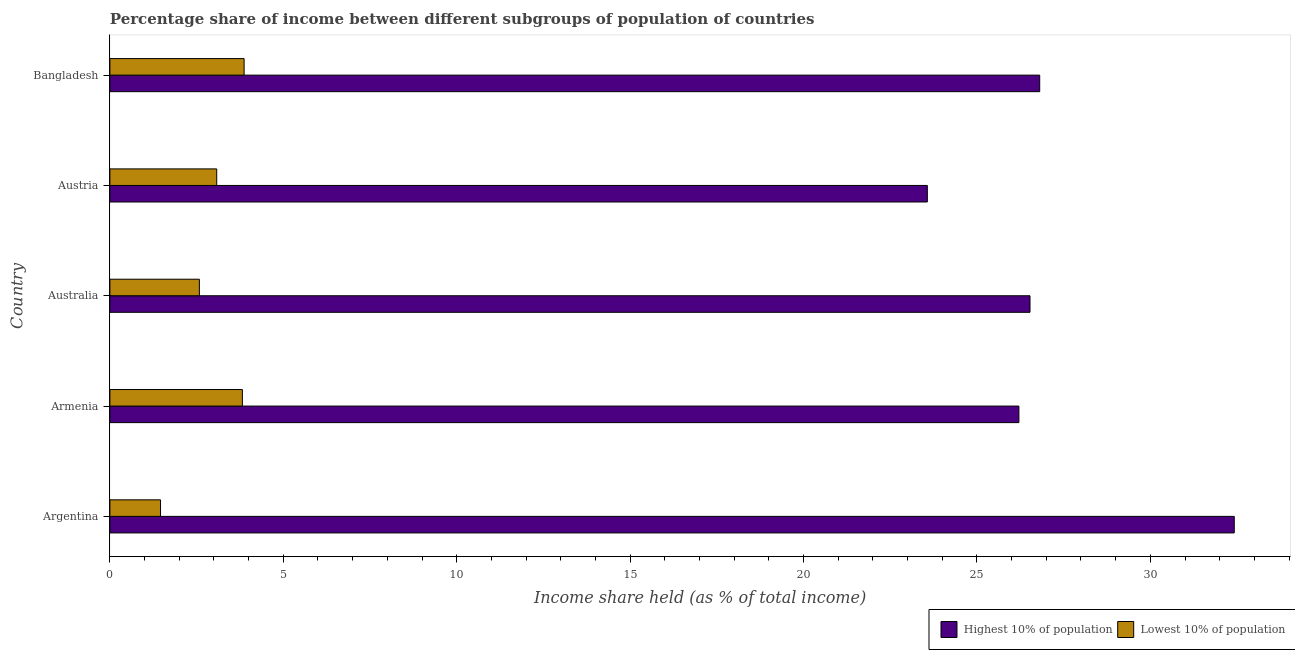How many different coloured bars are there?
Your answer should be compact. 2. How many groups of bars are there?
Provide a short and direct response. 5. Are the number of bars per tick equal to the number of legend labels?
Give a very brief answer. Yes. Are the number of bars on each tick of the Y-axis equal?
Your answer should be very brief. Yes. How many bars are there on the 2nd tick from the top?
Offer a very short reply. 2. What is the label of the 1st group of bars from the top?
Make the answer very short. Bangladesh. What is the income share held by lowest 10% of the population in Bangladesh?
Your answer should be compact. 3.87. Across all countries, what is the maximum income share held by highest 10% of the population?
Your answer should be very brief. 32.42. Across all countries, what is the minimum income share held by highest 10% of the population?
Give a very brief answer. 23.57. In which country was the income share held by lowest 10% of the population minimum?
Offer a terse response. Argentina. What is the total income share held by highest 10% of the population in the graph?
Give a very brief answer. 135.54. What is the difference between the income share held by highest 10% of the population in Austria and that in Bangladesh?
Your response must be concise. -3.24. What is the difference between the income share held by lowest 10% of the population in Argentina and the income share held by highest 10% of the population in Austria?
Your answer should be very brief. -22.11. What is the average income share held by lowest 10% of the population per country?
Ensure brevity in your answer.  2.96. What is the difference between the income share held by lowest 10% of the population and income share held by highest 10% of the population in Australia?
Give a very brief answer. -23.95. What is the ratio of the income share held by highest 10% of the population in Argentina to that in Australia?
Your answer should be compact. 1.22. Is the income share held by lowest 10% of the population in Argentina less than that in Australia?
Offer a very short reply. Yes. What is the difference between the highest and the second highest income share held by highest 10% of the population?
Your response must be concise. 5.61. What is the difference between the highest and the lowest income share held by highest 10% of the population?
Your answer should be compact. 8.85. In how many countries, is the income share held by highest 10% of the population greater than the average income share held by highest 10% of the population taken over all countries?
Give a very brief answer. 1. Is the sum of the income share held by lowest 10% of the population in Austria and Bangladesh greater than the maximum income share held by highest 10% of the population across all countries?
Your answer should be very brief. No. What does the 2nd bar from the top in Armenia represents?
Make the answer very short. Highest 10% of population. What does the 2nd bar from the bottom in Bangladesh represents?
Ensure brevity in your answer.  Lowest 10% of population. How many bars are there?
Keep it short and to the point. 10. What is the difference between two consecutive major ticks on the X-axis?
Offer a very short reply. 5. Does the graph contain any zero values?
Ensure brevity in your answer.  No. How many legend labels are there?
Keep it short and to the point. 2. How are the legend labels stacked?
Your answer should be compact. Horizontal. What is the title of the graph?
Keep it short and to the point. Percentage share of income between different subgroups of population of countries. Does "Diarrhea" appear as one of the legend labels in the graph?
Your response must be concise. No. What is the label or title of the X-axis?
Your answer should be compact. Income share held (as % of total income). What is the Income share held (as % of total income) in Highest 10% of population in Argentina?
Your answer should be very brief. 32.42. What is the Income share held (as % of total income) in Lowest 10% of population in Argentina?
Your answer should be very brief. 1.46. What is the Income share held (as % of total income) in Highest 10% of population in Armenia?
Provide a succinct answer. 26.21. What is the Income share held (as % of total income) in Lowest 10% of population in Armenia?
Make the answer very short. 3.82. What is the Income share held (as % of total income) of Highest 10% of population in Australia?
Your answer should be very brief. 26.53. What is the Income share held (as % of total income) in Lowest 10% of population in Australia?
Make the answer very short. 2.58. What is the Income share held (as % of total income) of Highest 10% of population in Austria?
Provide a short and direct response. 23.57. What is the Income share held (as % of total income) of Lowest 10% of population in Austria?
Make the answer very short. 3.08. What is the Income share held (as % of total income) in Highest 10% of population in Bangladesh?
Offer a terse response. 26.81. What is the Income share held (as % of total income) in Lowest 10% of population in Bangladesh?
Ensure brevity in your answer.  3.87. Across all countries, what is the maximum Income share held (as % of total income) of Highest 10% of population?
Offer a very short reply. 32.42. Across all countries, what is the maximum Income share held (as % of total income) in Lowest 10% of population?
Your answer should be compact. 3.87. Across all countries, what is the minimum Income share held (as % of total income) in Highest 10% of population?
Ensure brevity in your answer.  23.57. Across all countries, what is the minimum Income share held (as % of total income) of Lowest 10% of population?
Make the answer very short. 1.46. What is the total Income share held (as % of total income) of Highest 10% of population in the graph?
Your answer should be very brief. 135.54. What is the total Income share held (as % of total income) of Lowest 10% of population in the graph?
Your answer should be compact. 14.81. What is the difference between the Income share held (as % of total income) of Highest 10% of population in Argentina and that in Armenia?
Give a very brief answer. 6.21. What is the difference between the Income share held (as % of total income) of Lowest 10% of population in Argentina and that in Armenia?
Make the answer very short. -2.36. What is the difference between the Income share held (as % of total income) in Highest 10% of population in Argentina and that in Australia?
Provide a succinct answer. 5.89. What is the difference between the Income share held (as % of total income) of Lowest 10% of population in Argentina and that in Australia?
Ensure brevity in your answer.  -1.12. What is the difference between the Income share held (as % of total income) of Highest 10% of population in Argentina and that in Austria?
Ensure brevity in your answer.  8.85. What is the difference between the Income share held (as % of total income) in Lowest 10% of population in Argentina and that in Austria?
Your answer should be very brief. -1.62. What is the difference between the Income share held (as % of total income) in Highest 10% of population in Argentina and that in Bangladesh?
Offer a terse response. 5.61. What is the difference between the Income share held (as % of total income) of Lowest 10% of population in Argentina and that in Bangladesh?
Your response must be concise. -2.41. What is the difference between the Income share held (as % of total income) in Highest 10% of population in Armenia and that in Australia?
Ensure brevity in your answer.  -0.32. What is the difference between the Income share held (as % of total income) in Lowest 10% of population in Armenia and that in Australia?
Offer a very short reply. 1.24. What is the difference between the Income share held (as % of total income) in Highest 10% of population in Armenia and that in Austria?
Offer a terse response. 2.64. What is the difference between the Income share held (as % of total income) of Lowest 10% of population in Armenia and that in Austria?
Your answer should be compact. 0.74. What is the difference between the Income share held (as % of total income) of Highest 10% of population in Australia and that in Austria?
Ensure brevity in your answer.  2.96. What is the difference between the Income share held (as % of total income) in Highest 10% of population in Australia and that in Bangladesh?
Your answer should be very brief. -0.28. What is the difference between the Income share held (as % of total income) of Lowest 10% of population in Australia and that in Bangladesh?
Make the answer very short. -1.29. What is the difference between the Income share held (as % of total income) in Highest 10% of population in Austria and that in Bangladesh?
Offer a very short reply. -3.24. What is the difference between the Income share held (as % of total income) in Lowest 10% of population in Austria and that in Bangladesh?
Ensure brevity in your answer.  -0.79. What is the difference between the Income share held (as % of total income) of Highest 10% of population in Argentina and the Income share held (as % of total income) of Lowest 10% of population in Armenia?
Offer a very short reply. 28.6. What is the difference between the Income share held (as % of total income) in Highest 10% of population in Argentina and the Income share held (as % of total income) in Lowest 10% of population in Australia?
Your answer should be very brief. 29.84. What is the difference between the Income share held (as % of total income) of Highest 10% of population in Argentina and the Income share held (as % of total income) of Lowest 10% of population in Austria?
Your answer should be compact. 29.34. What is the difference between the Income share held (as % of total income) of Highest 10% of population in Argentina and the Income share held (as % of total income) of Lowest 10% of population in Bangladesh?
Your answer should be very brief. 28.55. What is the difference between the Income share held (as % of total income) of Highest 10% of population in Armenia and the Income share held (as % of total income) of Lowest 10% of population in Australia?
Provide a succinct answer. 23.63. What is the difference between the Income share held (as % of total income) of Highest 10% of population in Armenia and the Income share held (as % of total income) of Lowest 10% of population in Austria?
Ensure brevity in your answer.  23.13. What is the difference between the Income share held (as % of total income) of Highest 10% of population in Armenia and the Income share held (as % of total income) of Lowest 10% of population in Bangladesh?
Offer a very short reply. 22.34. What is the difference between the Income share held (as % of total income) of Highest 10% of population in Australia and the Income share held (as % of total income) of Lowest 10% of population in Austria?
Provide a short and direct response. 23.45. What is the difference between the Income share held (as % of total income) of Highest 10% of population in Australia and the Income share held (as % of total income) of Lowest 10% of population in Bangladesh?
Keep it short and to the point. 22.66. What is the average Income share held (as % of total income) of Highest 10% of population per country?
Your answer should be very brief. 27.11. What is the average Income share held (as % of total income) of Lowest 10% of population per country?
Offer a very short reply. 2.96. What is the difference between the Income share held (as % of total income) of Highest 10% of population and Income share held (as % of total income) of Lowest 10% of population in Argentina?
Make the answer very short. 30.96. What is the difference between the Income share held (as % of total income) of Highest 10% of population and Income share held (as % of total income) of Lowest 10% of population in Armenia?
Provide a succinct answer. 22.39. What is the difference between the Income share held (as % of total income) in Highest 10% of population and Income share held (as % of total income) in Lowest 10% of population in Australia?
Make the answer very short. 23.95. What is the difference between the Income share held (as % of total income) in Highest 10% of population and Income share held (as % of total income) in Lowest 10% of population in Austria?
Ensure brevity in your answer.  20.49. What is the difference between the Income share held (as % of total income) in Highest 10% of population and Income share held (as % of total income) in Lowest 10% of population in Bangladesh?
Give a very brief answer. 22.94. What is the ratio of the Income share held (as % of total income) in Highest 10% of population in Argentina to that in Armenia?
Offer a very short reply. 1.24. What is the ratio of the Income share held (as % of total income) in Lowest 10% of population in Argentina to that in Armenia?
Your response must be concise. 0.38. What is the ratio of the Income share held (as % of total income) in Highest 10% of population in Argentina to that in Australia?
Your response must be concise. 1.22. What is the ratio of the Income share held (as % of total income) in Lowest 10% of population in Argentina to that in Australia?
Offer a very short reply. 0.57. What is the ratio of the Income share held (as % of total income) in Highest 10% of population in Argentina to that in Austria?
Ensure brevity in your answer.  1.38. What is the ratio of the Income share held (as % of total income) in Lowest 10% of population in Argentina to that in Austria?
Your response must be concise. 0.47. What is the ratio of the Income share held (as % of total income) of Highest 10% of population in Argentina to that in Bangladesh?
Make the answer very short. 1.21. What is the ratio of the Income share held (as % of total income) of Lowest 10% of population in Argentina to that in Bangladesh?
Your answer should be compact. 0.38. What is the ratio of the Income share held (as % of total income) of Highest 10% of population in Armenia to that in Australia?
Offer a very short reply. 0.99. What is the ratio of the Income share held (as % of total income) in Lowest 10% of population in Armenia to that in Australia?
Give a very brief answer. 1.48. What is the ratio of the Income share held (as % of total income) of Highest 10% of population in Armenia to that in Austria?
Offer a terse response. 1.11. What is the ratio of the Income share held (as % of total income) in Lowest 10% of population in Armenia to that in Austria?
Keep it short and to the point. 1.24. What is the ratio of the Income share held (as % of total income) of Highest 10% of population in Armenia to that in Bangladesh?
Keep it short and to the point. 0.98. What is the ratio of the Income share held (as % of total income) in Lowest 10% of population in Armenia to that in Bangladesh?
Your response must be concise. 0.99. What is the ratio of the Income share held (as % of total income) in Highest 10% of population in Australia to that in Austria?
Provide a short and direct response. 1.13. What is the ratio of the Income share held (as % of total income) of Lowest 10% of population in Australia to that in Austria?
Provide a succinct answer. 0.84. What is the ratio of the Income share held (as % of total income) of Lowest 10% of population in Australia to that in Bangladesh?
Offer a terse response. 0.67. What is the ratio of the Income share held (as % of total income) of Highest 10% of population in Austria to that in Bangladesh?
Your answer should be compact. 0.88. What is the ratio of the Income share held (as % of total income) in Lowest 10% of population in Austria to that in Bangladesh?
Offer a terse response. 0.8. What is the difference between the highest and the second highest Income share held (as % of total income) in Highest 10% of population?
Offer a terse response. 5.61. What is the difference between the highest and the second highest Income share held (as % of total income) of Lowest 10% of population?
Your response must be concise. 0.05. What is the difference between the highest and the lowest Income share held (as % of total income) of Highest 10% of population?
Make the answer very short. 8.85. What is the difference between the highest and the lowest Income share held (as % of total income) of Lowest 10% of population?
Provide a succinct answer. 2.41. 